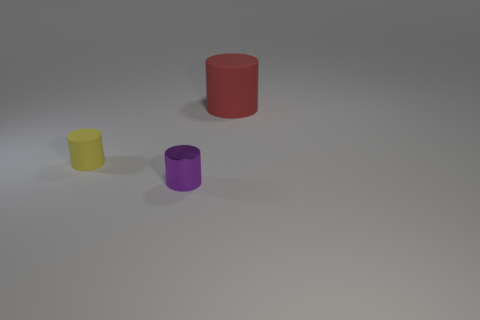Is there any other thing that is the same material as the purple cylinder?
Your answer should be compact. No. How many other objects are the same size as the metallic cylinder?
Keep it short and to the point. 1. There is a tiny yellow cylinder; are there any large red cylinders on the right side of it?
Your answer should be compact. Yes. What is the color of the matte thing behind the matte cylinder that is in front of the rubber thing right of the small yellow object?
Keep it short and to the point. Red. Is there another metal thing of the same shape as the big thing?
Your answer should be compact. Yes. There is another object that is the same size as the purple object; what color is it?
Your response must be concise. Yellow. What is the object that is behind the small yellow matte object made of?
Offer a terse response. Rubber. Is the number of large things that are behind the big red rubber cylinder the same as the number of large purple cylinders?
Ensure brevity in your answer.  Yes. What number of tiny purple cylinders have the same material as the large thing?
Provide a succinct answer. 0. What color is the big thing that is the same material as the small yellow cylinder?
Offer a terse response. Red. 